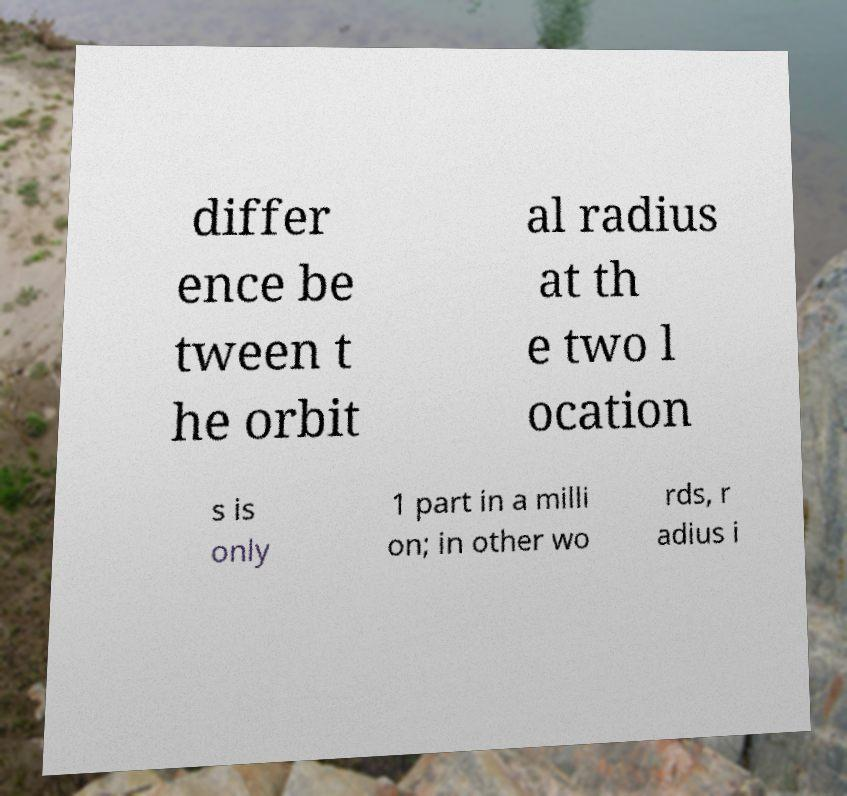Could you extract and type out the text from this image? differ ence be tween t he orbit al radius at th e two l ocation s is only 1 part in a milli on; in other wo rds, r adius i 